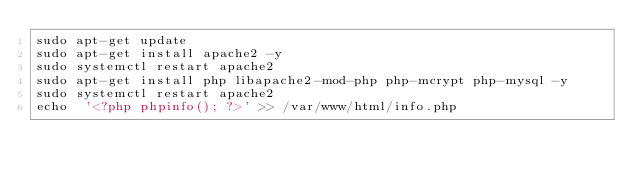Convert code to text. <code><loc_0><loc_0><loc_500><loc_500><_Bash_>sudo apt-get update
sudo apt-get install apache2 -y
sudo systemctl restart apache2
sudo apt-get install php libapache2-mod-php php-mcrypt php-mysql -y
sudo systemctl restart apache2
echo  '<?php phpinfo(); ?>' >> /var/www/html/info.php
 </code> 